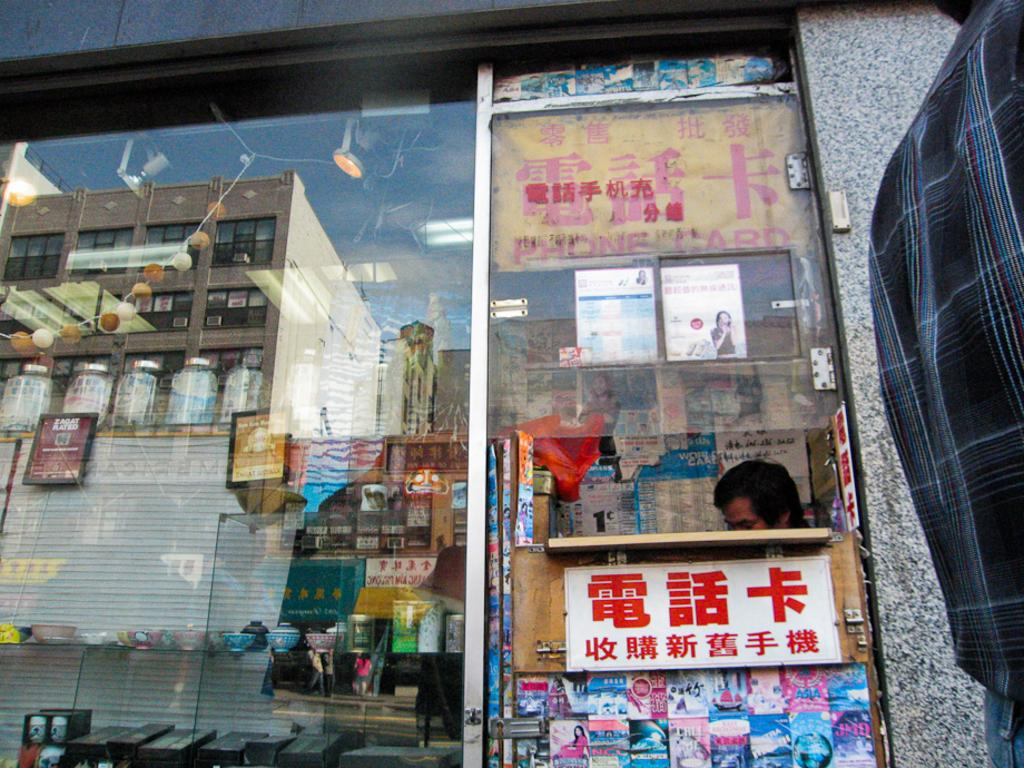<image>
Provide a brief description of the given image. A person sits behind a counter beneath a sign advertising PHONE CARD. 